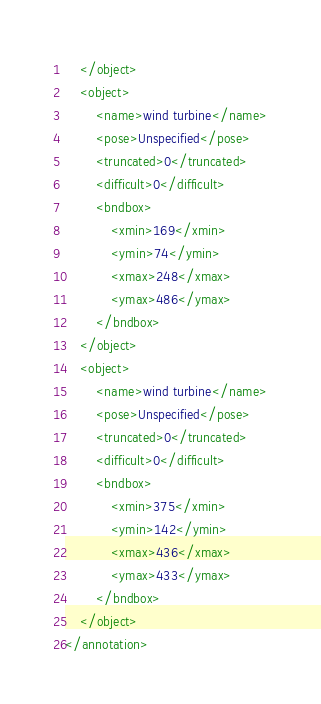Convert code to text. <code><loc_0><loc_0><loc_500><loc_500><_XML_>	</object>
	<object>
		<name>wind turbine</name>
		<pose>Unspecified</pose>
		<truncated>0</truncated>
		<difficult>0</difficult>
		<bndbox>
			<xmin>169</xmin>
			<ymin>74</ymin>
			<xmax>248</xmax>
			<ymax>486</ymax>
		</bndbox>
	</object>
	<object>
		<name>wind turbine</name>
		<pose>Unspecified</pose>
		<truncated>0</truncated>
		<difficult>0</difficult>
		<bndbox>
			<xmin>375</xmin>
			<ymin>142</ymin>
			<xmax>436</xmax>
			<ymax>433</ymax>
		</bndbox>
	</object>
</annotation>
</code> 